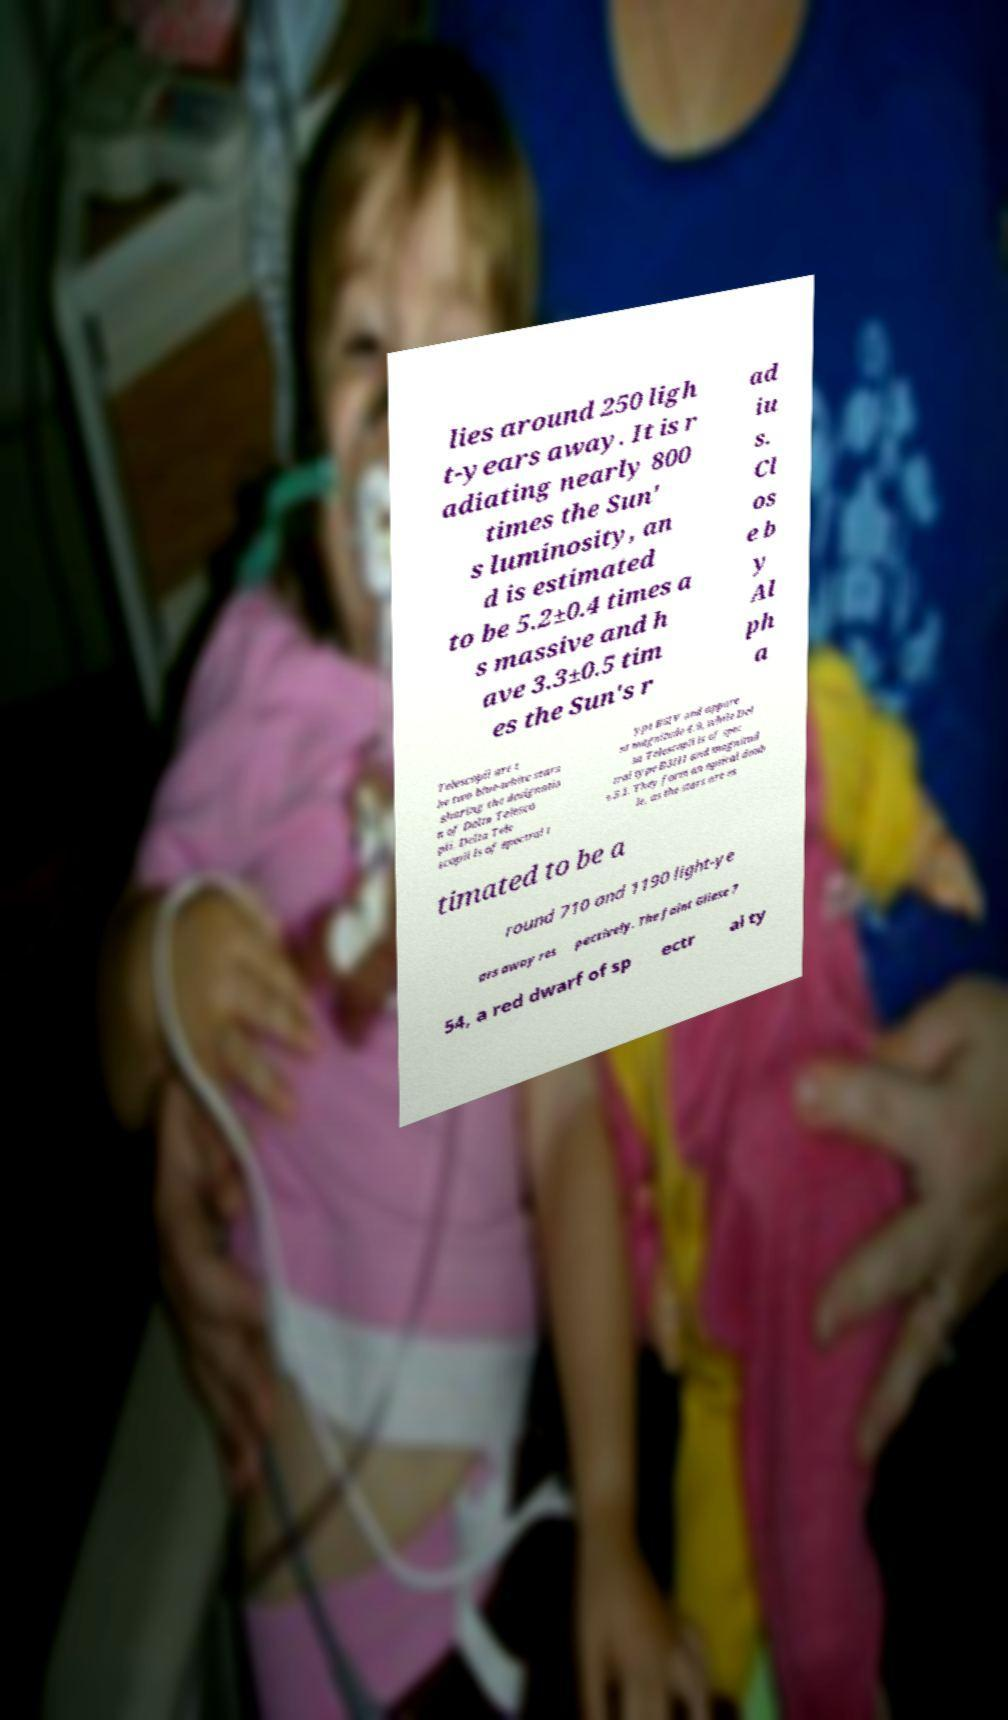There's text embedded in this image that I need extracted. Can you transcribe it verbatim? lies around 250 ligh t-years away. It is r adiating nearly 800 times the Sun' s luminosity, an d is estimated to be 5.2±0.4 times a s massive and h ave 3.3±0.5 tim es the Sun's r ad iu s. Cl os e b y Al ph a Telescopii are t he two blue-white stars sharing the designatio n of Delta Telesco pii. Delta Tele scopii is of spectral t ype B6IV and appare nt magnitude 4.9, while Del ta Telescopii is of spec tral type B3III and magnitud e 5.1. They form an optical doub le, as the stars are es timated to be a round 710 and 1190 light-ye ars away res pectively. The faint Gliese 7 54, a red dwarf of sp ectr al ty 